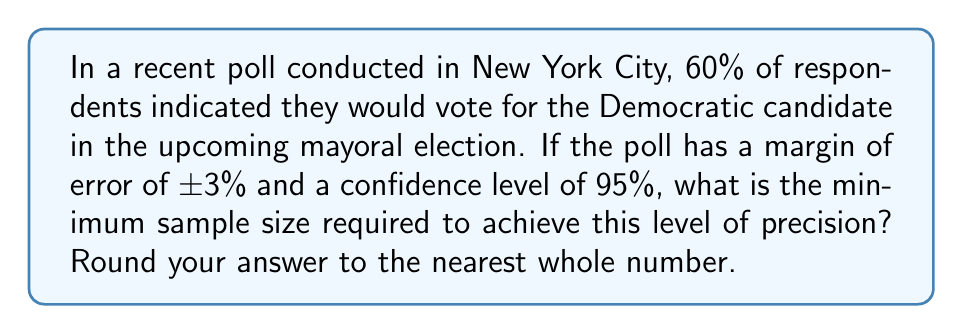Can you solve this math problem? To solve this problem, we'll use the formula for sample size calculation in polling:

$$n = \frac{z^2 \cdot p(1-p)}{e^2}$$

Where:
$n$ = sample size
$z$ = z-score (1.96 for 95% confidence level)
$p$ = proportion (0.60 in this case)
$e$ = margin of error (0.03)

Step 1: Determine the z-score for 95% confidence level
$z = 1.96$

Step 2: Calculate $p(1-p)$
$p(1-p) = 0.60(1-0.60) = 0.60(0.40) = 0.24$

Step 3: Square the z-score and margin of error
$z^2 = 1.96^2 = 3.8416$
$e^2 = 0.03^2 = 0.0009$

Step 4: Apply the formula
$$n = \frac{3.8416 \cdot 0.24}{0.0009} = 1024.4267$$

Step 5: Round to the nearest whole number
$n \approx 1024$

This sample size ensures that we can be 95% confident that our poll results are within ±3% of the true population proportion, given the observed 60% support for the Democratic candidate.
Answer: 1024 